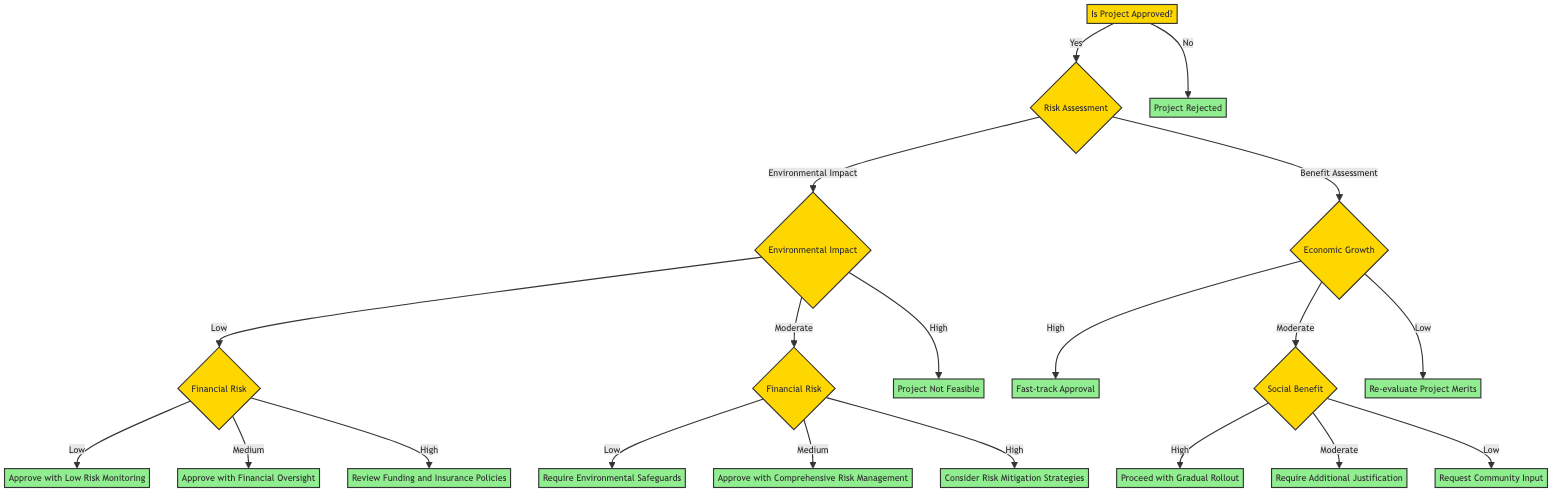Is the decision to approve the project contingent on risk assessment? Yes, the decision tree shows that "Is Project Approved?" leads to further evaluations regarding "Risk Assessment". The approval status depends on these assessments.
Answer: Yes What action is taken if the environmental impact is rated as high? If the environmental impact is "High", the diagram indicates that no further action is viable as the project is deemed "Not Feasible."
Answer: Project Not Feasible How many outcomes are linked to low financial risk under low environmental impact? The "Low" environmental impact leads to three possible outcomes based on financial risk: "Approve with Low Risk Monitoring," "Approve with Financial Oversight," and "Review Funding and Insurance Policies." Thus, the total number of outcomes is three.
Answer: 3 What is the result if economic growth is assessed as low? When economic growth is "Low," the flowchart directs to "Re-evaluate Project Merits," indicating that the project needs further examination due to its low potential benefits.
Answer: Re-evaluate Project Merits What step follows if the financial risk is assessed as medium under moderate environmental impact? Under "Moderate" environmental impact and if the financial risk is "Medium," the diagram indicates the next step would be "Approve with Comprehensive Risk Management."
Answer: Approve with Comprehensive Risk Management What happens if social benefit is rated low under moderate economic growth? If social benefit is deemed "Low" while economic growth is "Moderate," the diagram suggests "Request Community Input," meaning stakeholder advice is sought before proceeding.
Answer: Request Community Input How many decision nodes are present in the diagram? The diagram has a total of six decision nodes: "Is Project Approved," "Risk Assessment," "Environmental Impact," "Financial Risk," "Benefit Assessment," and "Economic Growth," thus totaling six.
Answer: 6 What is the consequence of rejecting a project? The decision tree directly states that if "Is Project Approved?" is answered with "No," then the consequence is simply "Project Rejected."
Answer: Project Rejected 